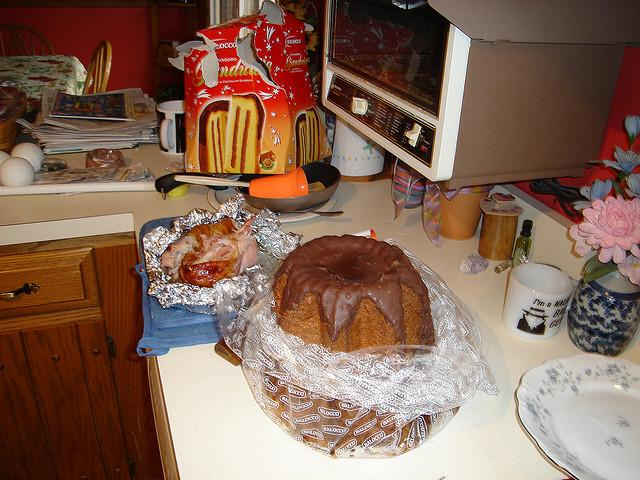What is the cake on top of? counter 